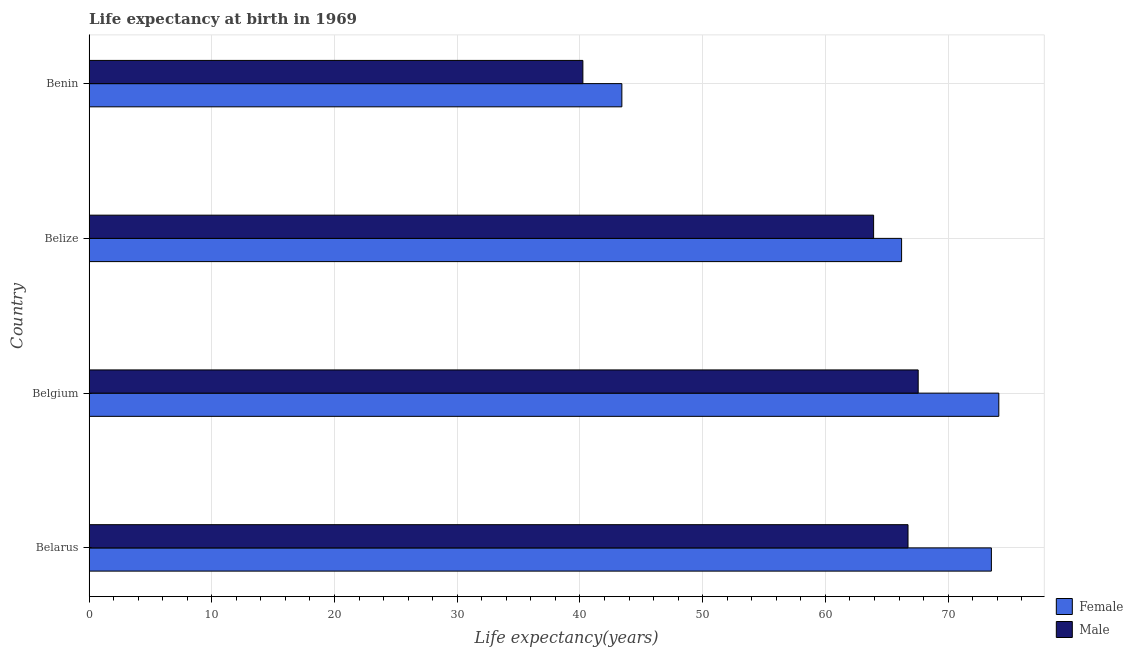How many different coloured bars are there?
Your answer should be very brief. 2. Are the number of bars per tick equal to the number of legend labels?
Ensure brevity in your answer.  Yes. Are the number of bars on each tick of the Y-axis equal?
Offer a terse response. Yes. How many bars are there on the 4th tick from the top?
Give a very brief answer. 2. How many bars are there on the 4th tick from the bottom?
Provide a short and direct response. 2. What is the label of the 1st group of bars from the top?
Ensure brevity in your answer.  Benin. What is the life expectancy(male) in Belgium?
Offer a very short reply. 67.56. Across all countries, what is the maximum life expectancy(male)?
Your answer should be very brief. 67.56. Across all countries, what is the minimum life expectancy(female)?
Provide a short and direct response. 43.41. In which country was the life expectancy(female) maximum?
Offer a very short reply. Belgium. In which country was the life expectancy(female) minimum?
Your answer should be very brief. Benin. What is the total life expectancy(male) in the graph?
Provide a short and direct response. 238.45. What is the difference between the life expectancy(male) in Belize and that in Benin?
Keep it short and to the point. 23.69. What is the difference between the life expectancy(male) in Belgium and the life expectancy(female) in Belize?
Keep it short and to the point. 1.35. What is the average life expectancy(male) per country?
Keep it short and to the point. 59.61. What is the difference between the life expectancy(female) and life expectancy(male) in Belarus?
Offer a very short reply. 6.79. In how many countries, is the life expectancy(male) greater than 56 years?
Your answer should be compact. 3. What is the difference between the highest and the second highest life expectancy(male)?
Your answer should be compact. 0.83. What is the difference between the highest and the lowest life expectancy(male)?
Ensure brevity in your answer.  27.32. Is the sum of the life expectancy(male) in Belize and Benin greater than the maximum life expectancy(female) across all countries?
Ensure brevity in your answer.  Yes. What does the 1st bar from the bottom in Belarus represents?
Make the answer very short. Female. How many bars are there?
Your answer should be compact. 8. Are all the bars in the graph horizontal?
Give a very brief answer. Yes. How many countries are there in the graph?
Ensure brevity in your answer.  4. Are the values on the major ticks of X-axis written in scientific E-notation?
Your response must be concise. No. Does the graph contain any zero values?
Ensure brevity in your answer.  No. How are the legend labels stacked?
Provide a short and direct response. Vertical. What is the title of the graph?
Offer a very short reply. Life expectancy at birth in 1969. Does "Female entrants" appear as one of the legend labels in the graph?
Provide a succinct answer. No. What is the label or title of the X-axis?
Offer a terse response. Life expectancy(years). What is the Life expectancy(years) of Female in Belarus?
Your answer should be compact. 73.53. What is the Life expectancy(years) of Male in Belarus?
Your answer should be very brief. 66.73. What is the Life expectancy(years) of Female in Belgium?
Your answer should be compact. 74.13. What is the Life expectancy(years) of Male in Belgium?
Make the answer very short. 67.56. What is the Life expectancy(years) in Female in Belize?
Ensure brevity in your answer.  66.21. What is the Life expectancy(years) in Male in Belize?
Your response must be concise. 63.93. What is the Life expectancy(years) in Female in Benin?
Make the answer very short. 43.41. What is the Life expectancy(years) of Male in Benin?
Ensure brevity in your answer.  40.24. Across all countries, what is the maximum Life expectancy(years) in Female?
Your answer should be compact. 74.13. Across all countries, what is the maximum Life expectancy(years) of Male?
Give a very brief answer. 67.56. Across all countries, what is the minimum Life expectancy(years) of Female?
Your answer should be very brief. 43.41. Across all countries, what is the minimum Life expectancy(years) of Male?
Offer a very short reply. 40.24. What is the total Life expectancy(years) in Female in the graph?
Provide a succinct answer. 257.27. What is the total Life expectancy(years) in Male in the graph?
Your response must be concise. 238.45. What is the difference between the Life expectancy(years) in Female in Belarus and that in Belgium?
Ensure brevity in your answer.  -0.6. What is the difference between the Life expectancy(years) of Male in Belarus and that in Belgium?
Your response must be concise. -0.83. What is the difference between the Life expectancy(years) in Female in Belarus and that in Belize?
Make the answer very short. 7.32. What is the difference between the Life expectancy(years) of Male in Belarus and that in Belize?
Your answer should be compact. 2.8. What is the difference between the Life expectancy(years) of Female in Belarus and that in Benin?
Keep it short and to the point. 30.11. What is the difference between the Life expectancy(years) in Male in Belarus and that in Benin?
Provide a short and direct response. 26.5. What is the difference between the Life expectancy(years) of Female in Belgium and that in Belize?
Provide a succinct answer. 7.92. What is the difference between the Life expectancy(years) of Male in Belgium and that in Belize?
Make the answer very short. 3.63. What is the difference between the Life expectancy(years) of Female in Belgium and that in Benin?
Offer a terse response. 30.72. What is the difference between the Life expectancy(years) of Male in Belgium and that in Benin?
Make the answer very short. 27.32. What is the difference between the Life expectancy(years) of Female in Belize and that in Benin?
Make the answer very short. 22.79. What is the difference between the Life expectancy(years) of Male in Belize and that in Benin?
Keep it short and to the point. 23.69. What is the difference between the Life expectancy(years) in Female in Belarus and the Life expectancy(years) in Male in Belgium?
Your response must be concise. 5.96. What is the difference between the Life expectancy(years) in Female in Belarus and the Life expectancy(years) in Male in Belize?
Your response must be concise. 9.6. What is the difference between the Life expectancy(years) of Female in Belarus and the Life expectancy(years) of Male in Benin?
Keep it short and to the point. 33.29. What is the difference between the Life expectancy(years) of Female in Belgium and the Life expectancy(years) of Male in Belize?
Your answer should be very brief. 10.2. What is the difference between the Life expectancy(years) in Female in Belgium and the Life expectancy(years) in Male in Benin?
Offer a very short reply. 33.89. What is the difference between the Life expectancy(years) in Female in Belize and the Life expectancy(years) in Male in Benin?
Your answer should be compact. 25.97. What is the average Life expectancy(years) in Female per country?
Keep it short and to the point. 64.32. What is the average Life expectancy(years) of Male per country?
Offer a terse response. 59.61. What is the difference between the Life expectancy(years) in Female and Life expectancy(years) in Male in Belarus?
Offer a very short reply. 6.79. What is the difference between the Life expectancy(years) of Female and Life expectancy(years) of Male in Belgium?
Offer a terse response. 6.57. What is the difference between the Life expectancy(years) of Female and Life expectancy(years) of Male in Belize?
Provide a succinct answer. 2.28. What is the difference between the Life expectancy(years) of Female and Life expectancy(years) of Male in Benin?
Your answer should be compact. 3.18. What is the ratio of the Life expectancy(years) in Female in Belarus to that in Belize?
Your answer should be compact. 1.11. What is the ratio of the Life expectancy(years) of Male in Belarus to that in Belize?
Give a very brief answer. 1.04. What is the ratio of the Life expectancy(years) in Female in Belarus to that in Benin?
Make the answer very short. 1.69. What is the ratio of the Life expectancy(years) in Male in Belarus to that in Benin?
Provide a short and direct response. 1.66. What is the ratio of the Life expectancy(years) in Female in Belgium to that in Belize?
Your answer should be compact. 1.12. What is the ratio of the Life expectancy(years) in Male in Belgium to that in Belize?
Your answer should be very brief. 1.06. What is the ratio of the Life expectancy(years) in Female in Belgium to that in Benin?
Provide a short and direct response. 1.71. What is the ratio of the Life expectancy(years) of Male in Belgium to that in Benin?
Give a very brief answer. 1.68. What is the ratio of the Life expectancy(years) of Female in Belize to that in Benin?
Your response must be concise. 1.53. What is the ratio of the Life expectancy(years) of Male in Belize to that in Benin?
Give a very brief answer. 1.59. What is the difference between the highest and the second highest Life expectancy(years) of Female?
Your answer should be compact. 0.6. What is the difference between the highest and the second highest Life expectancy(years) of Male?
Your response must be concise. 0.83. What is the difference between the highest and the lowest Life expectancy(years) in Female?
Provide a short and direct response. 30.72. What is the difference between the highest and the lowest Life expectancy(years) in Male?
Keep it short and to the point. 27.32. 